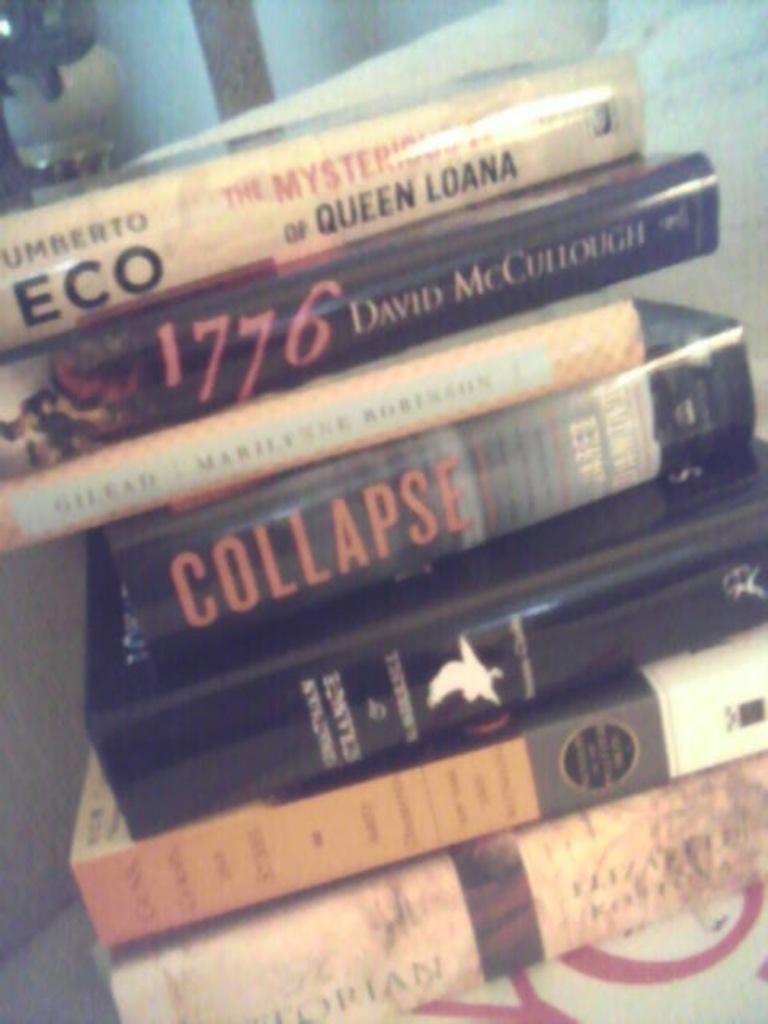What is the second book called?
Your answer should be very brief. 1776. What is the second book?
Your response must be concise. 1776. 